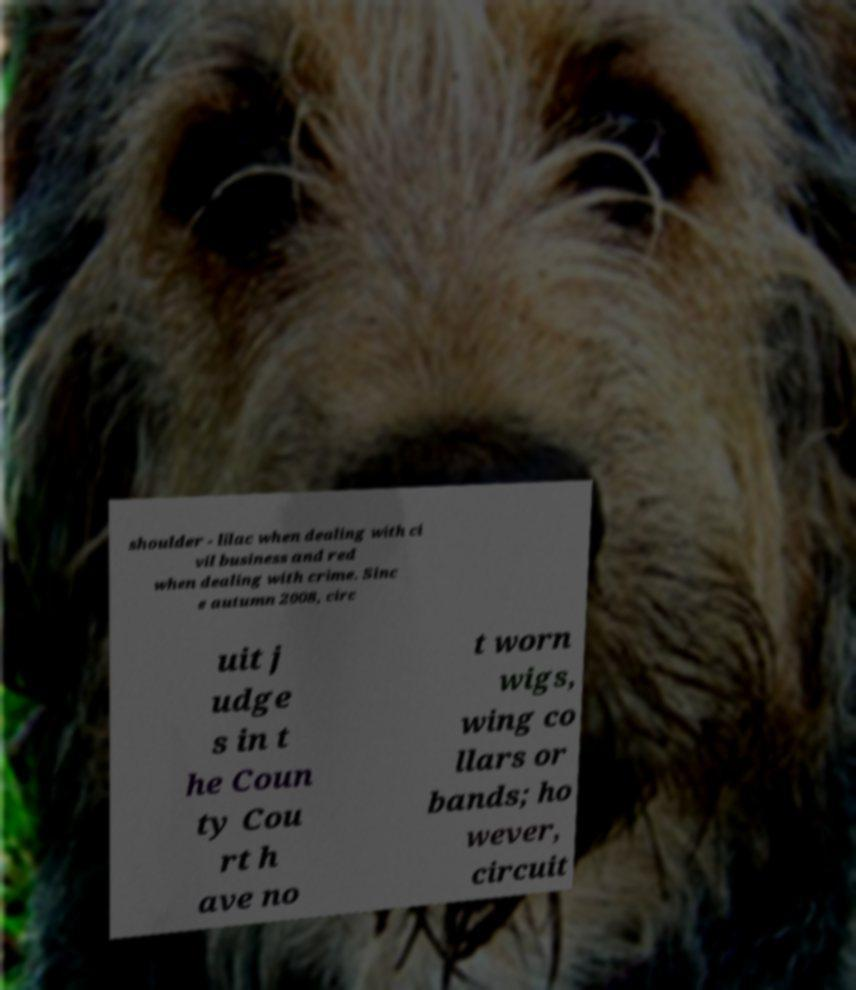For documentation purposes, I need the text within this image transcribed. Could you provide that? shoulder - lilac when dealing with ci vil business and red when dealing with crime. Sinc e autumn 2008, circ uit j udge s in t he Coun ty Cou rt h ave no t worn wigs, wing co llars or bands; ho wever, circuit 